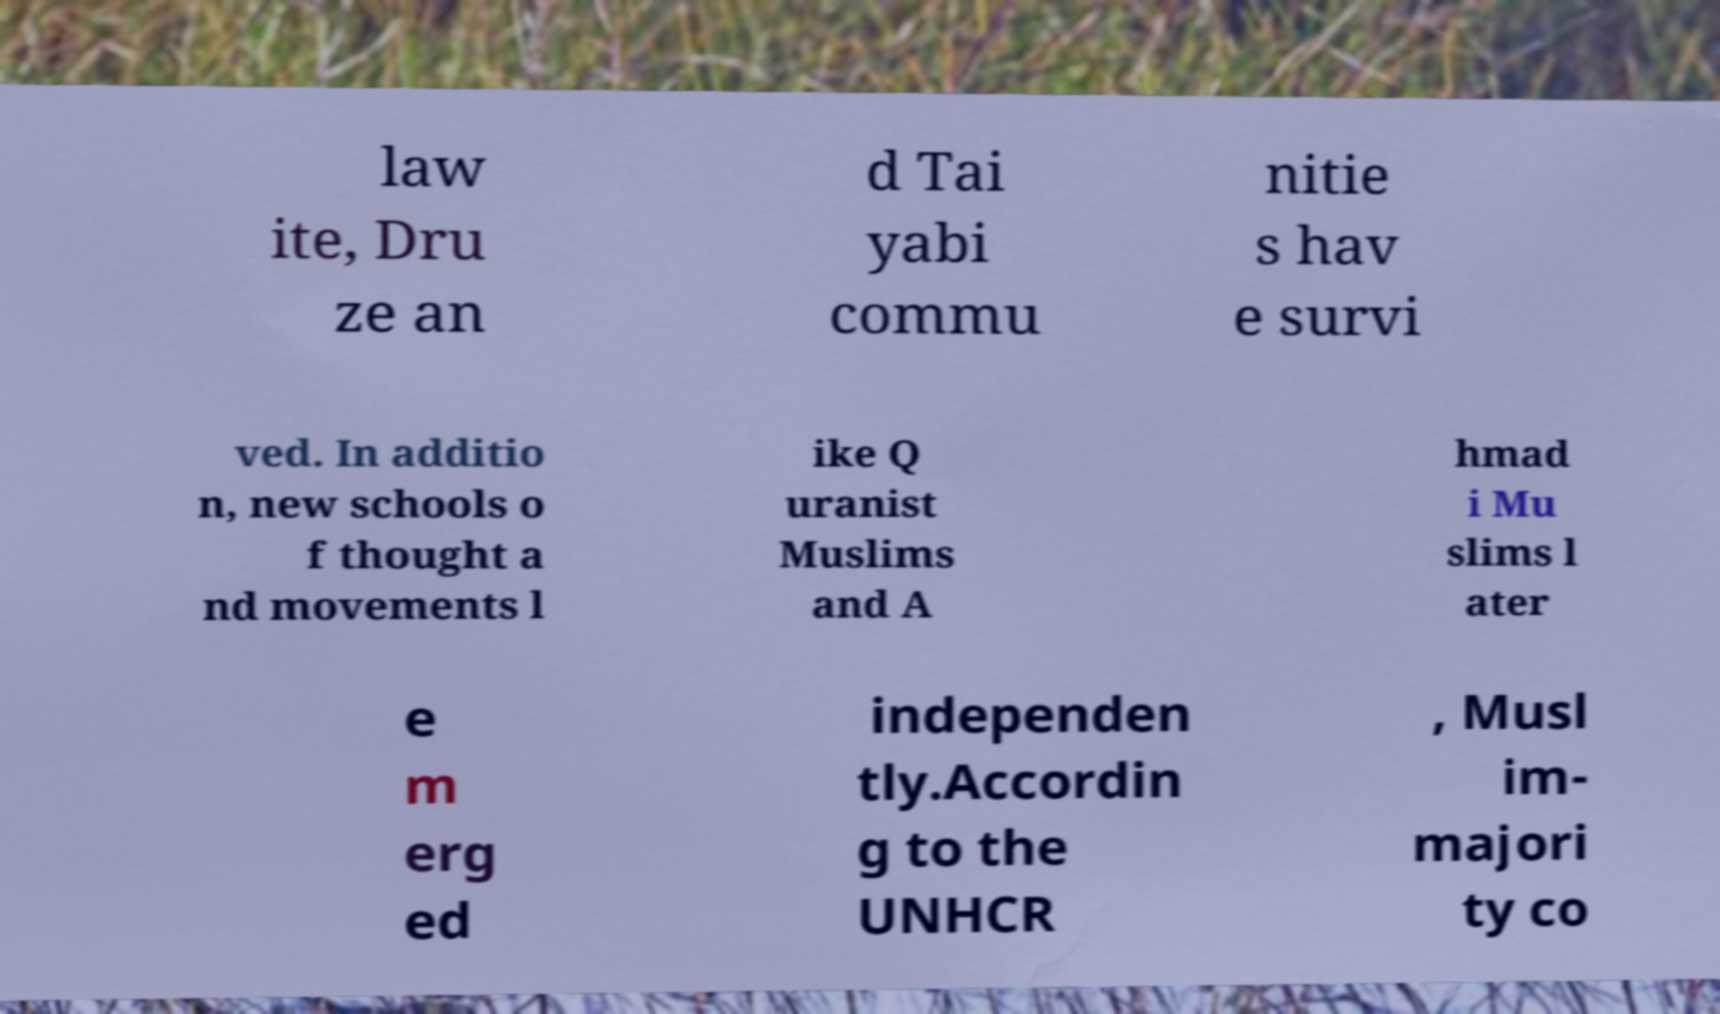What messages or text are displayed in this image? I need them in a readable, typed format. law ite, Dru ze an d Tai yabi commu nitie s hav e survi ved. In additio n, new schools o f thought a nd movements l ike Q uranist Muslims and A hmad i Mu slims l ater e m erg ed independen tly.Accordin g to the UNHCR , Musl im- majori ty co 